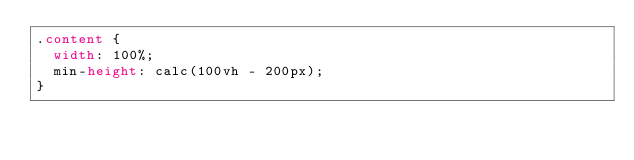Convert code to text. <code><loc_0><loc_0><loc_500><loc_500><_CSS_>.content {
  width: 100%;
  min-height: calc(100vh - 200px);
}</code> 